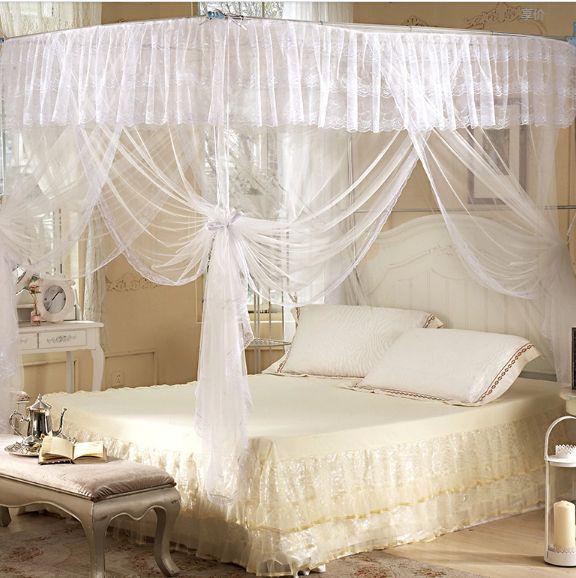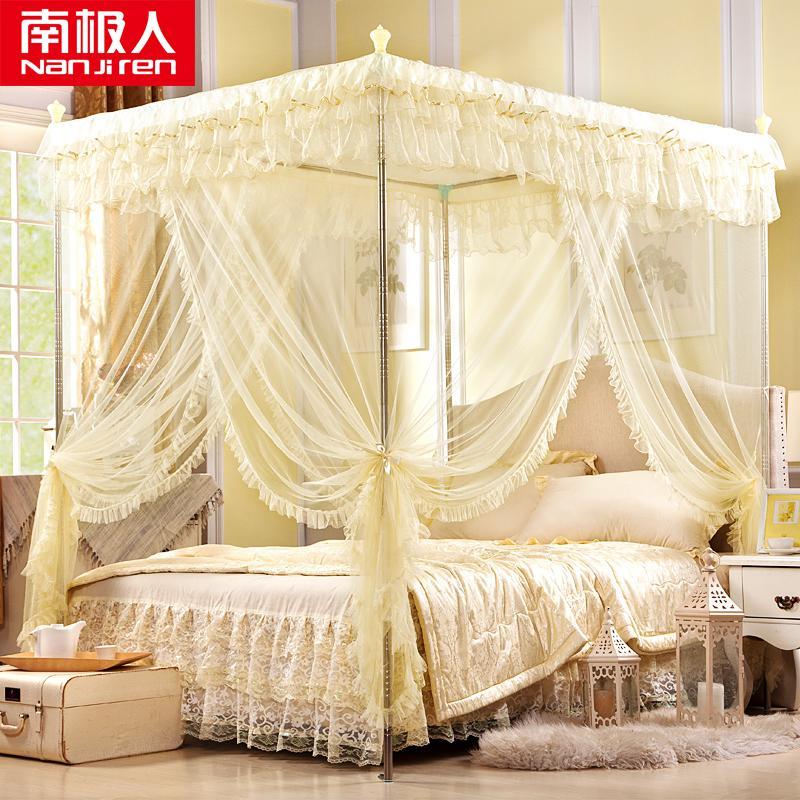The first image is the image on the left, the second image is the image on the right. Given the left and right images, does the statement "In each image, a four poster bed is covered with sheer draperies gathered at each post, with a top ruffle and visible knobs at the top of posts." hold true? Answer yes or no. No. The first image is the image on the left, the second image is the image on the right. Given the left and right images, does the statement "The wall and headboard behind at least one canopy bed feature a tufted, upholstered look." hold true? Answer yes or no. No. 